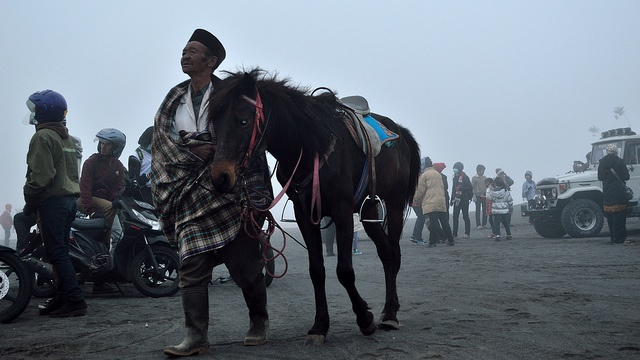Describe the objects in this image and their specific colors. I can see horse in lightblue, black, gray, and darkgray tones, people in lightblue, black, gray, darkgray, and purple tones, people in lightblue, black, gray, navy, and darkblue tones, motorcycle in lightblue, black, gray, purple, and darkblue tones, and truck in lightblue, gray, darkblue, and darkgray tones in this image. 